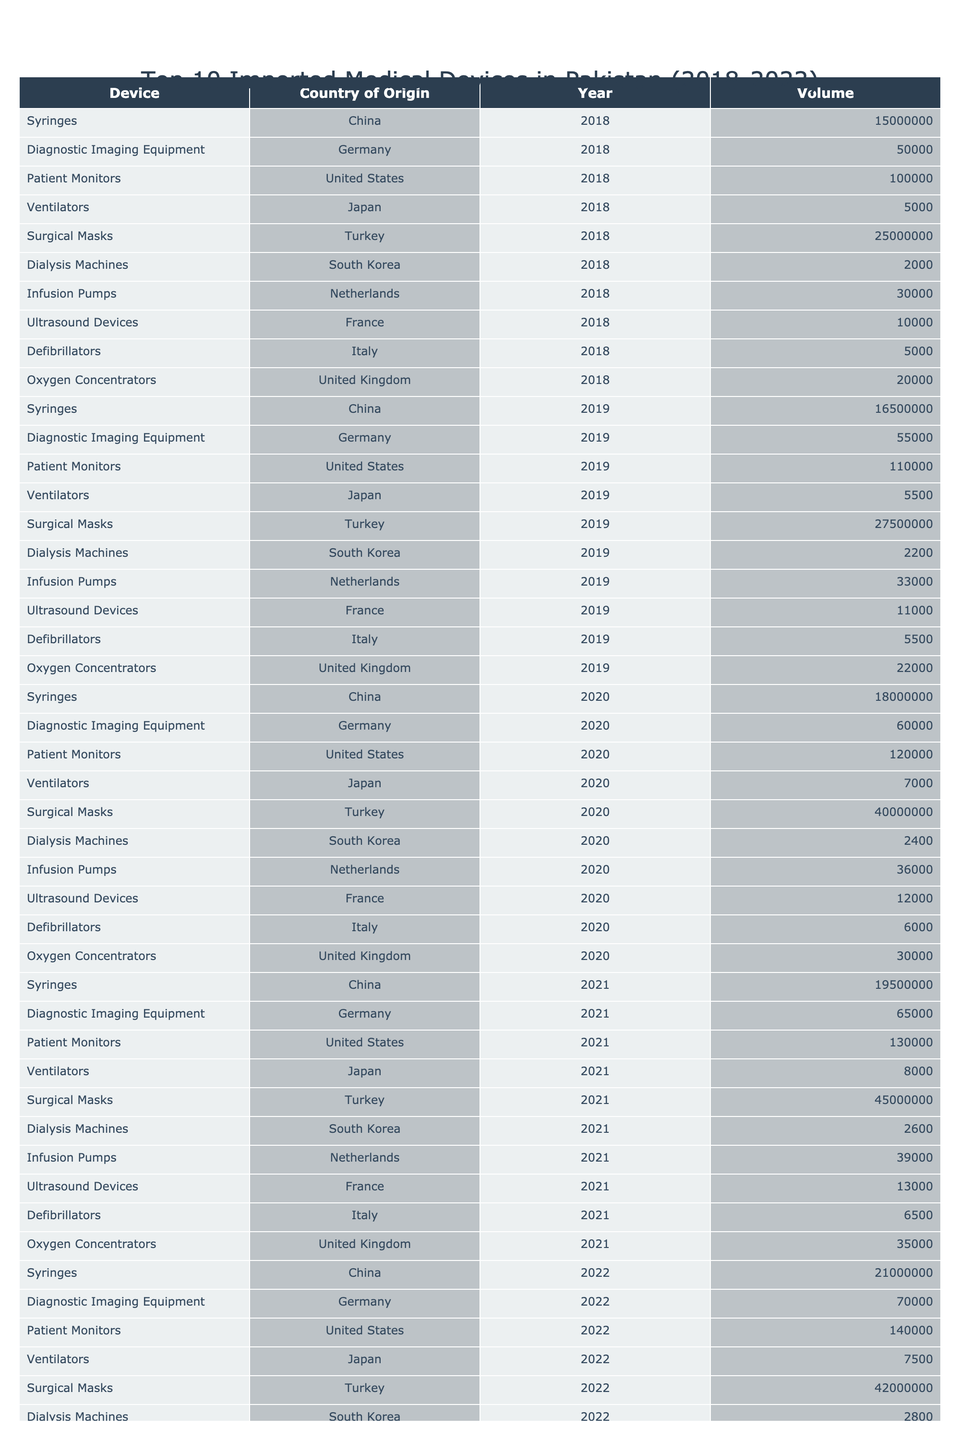What was the highest volume of syringes imported in a single year? The table shows that the highest volume of syringes imported was 21,000,000 in 2022.
Answer: 21,000,000 Which country is the origin of the most imported surgical masks? The data indicates that surgical masks were imported primarily from Turkey.
Answer: Turkey What is the volume of dialysis machines imported in 2021? Referring to the table, 2,600 dialysis machines were imported in 2021.
Answer: 2,600 Which medical device saw a decline in imports between 2021 and 2022? The volume of ventilators decreased from 8,000 in 2021 to 7,500 in 2022, indicating a decline.
Answer: Ventilators What was the total volume of infusion pumps imported from 2018 to 2022? The imported volumes are: 30,000 (2018) + 33,000 (2019) + 36,000 (2020) + 39,000 (2021) + 42,000 (2022). Summing these values gives a total of 180,000.
Answer: 180,000 In which year were the least number of oxygen concentrators imported? The table shows that the least volume of oxygen concentrators, 20,000, was imported in 2018.
Answer: 2018 Did the volume of diagnostic imaging equipment increase every year from 2018 to 2022? Yes, the volume increased from 50,000 in 2018 to 70,000 in 2022, showing a consistent increase each year.
Answer: Yes What was the average volume of patient monitors imported over the five years? The volumes of patient monitors are: 100,000 (2018), 110,000 (2019), 120,000 (2020), 130,000 (2021), and 140,000 (2022). The sum is 600,000, and dividing by 5 gives an average of 120,000.
Answer: 120,000 Which device had the largest import volume in 2020? The table indicates that surgical masks had the largest import volume of 40,000,000 in 2020.
Answer: Surgical Masks How many more syringes were imported in 2022 compared to 2018? The volume of syringes in 2022 was 21,000,000, and in 2018 it was 15,000,000. The difference is 21,000,000 - 15,000,000 = 6,000,000.
Answer: 6,000,000 